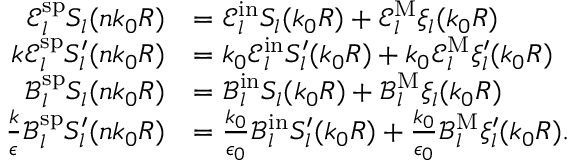Convert formula to latex. <formula><loc_0><loc_0><loc_500><loc_500>\begin{array} { r l } { \mathcal { E } _ { l } ^ { s p } S _ { l } ( n k _ { 0 } R ) } & { = \mathcal { E } _ { l } ^ { i n } S _ { l } ( k _ { 0 } R ) + \mathcal { E } _ { l } ^ { M } \xi _ { l } ( k _ { 0 } R ) } \\ { k \mathcal { E } _ { l } ^ { s p } S _ { l } ^ { \prime } ( n k _ { 0 } R ) } & { = k _ { 0 } \mathcal { E } _ { l } ^ { i n } S _ { l } ^ { \prime } ( k _ { 0 } R ) + k _ { 0 } \mathcal { E } _ { l } ^ { M } \xi _ { l } ^ { \prime } ( k _ { 0 } R ) } \\ { \mathcal { B } _ { l } ^ { s p } S _ { l } ( n k _ { 0 } R ) } & { = \mathcal { B } _ { l } ^ { i n } S _ { l } ( k _ { 0 } R ) + \mathcal { B } _ { l } ^ { M } \xi _ { l } ( k _ { 0 } R ) } \\ { \frac { k } { \epsilon } \mathcal { B } _ { l } ^ { s p } S _ { l } ^ { \prime } ( n k _ { 0 } R ) } & { = \frac { k _ { 0 } } { \epsilon _ { 0 } } \mathcal { B } _ { l } ^ { i n } S _ { l } ^ { \prime } ( k _ { 0 } R ) + \frac { k _ { 0 } } { \epsilon _ { 0 } } \mathcal { B } _ { l } ^ { M } \xi _ { l } ^ { \prime } ( k _ { 0 } R ) . } \end{array}</formula> 